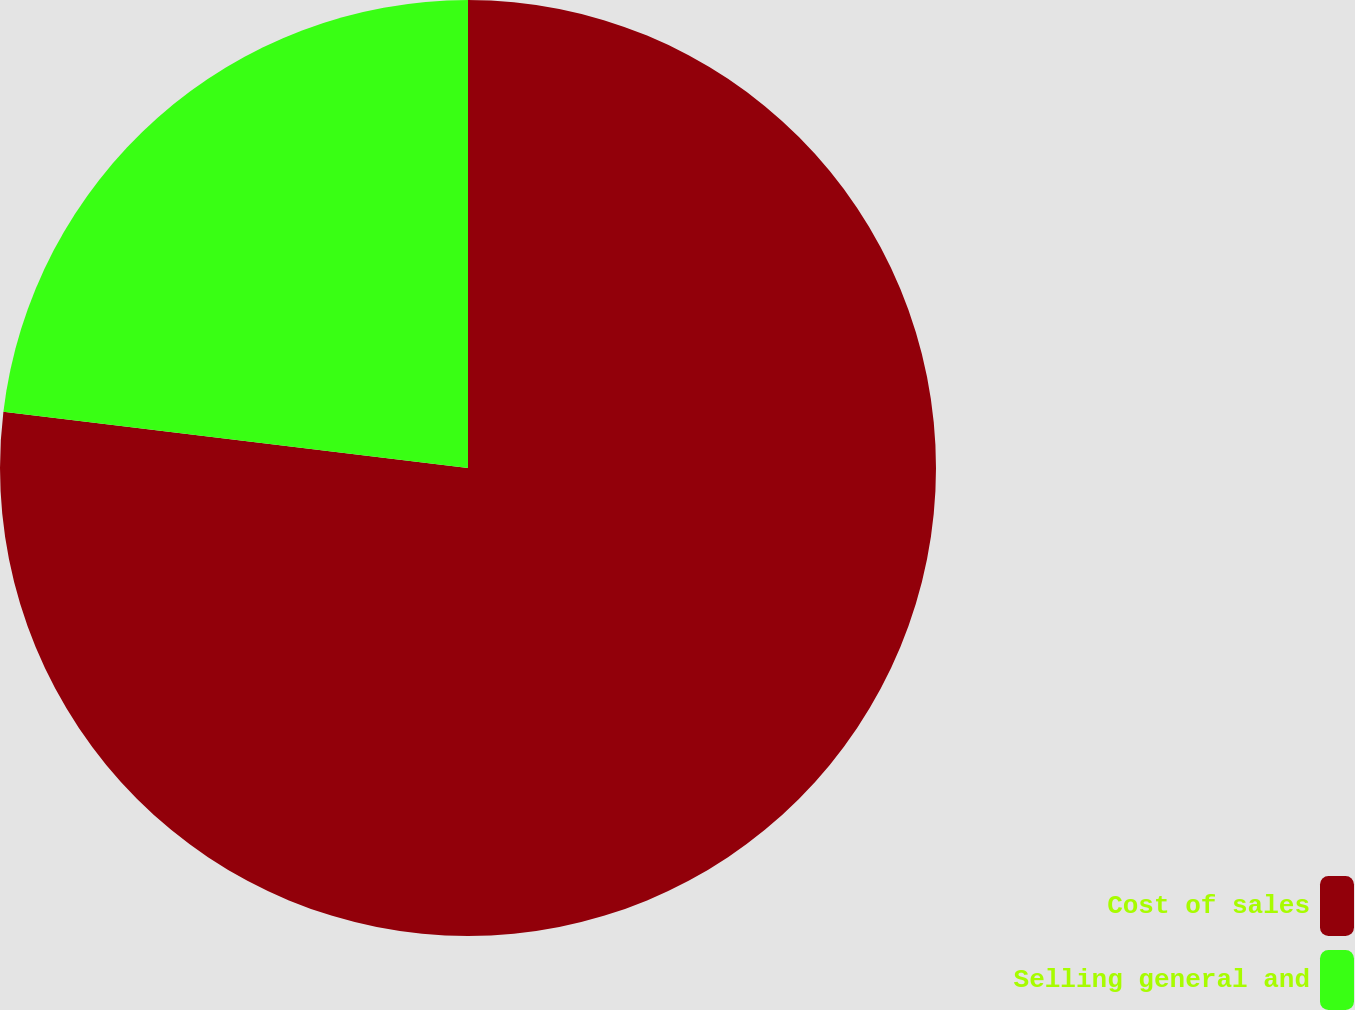<chart> <loc_0><loc_0><loc_500><loc_500><pie_chart><fcel>Cost of sales<fcel>Selling general and<nl><fcel>76.92%<fcel>23.08%<nl></chart> 